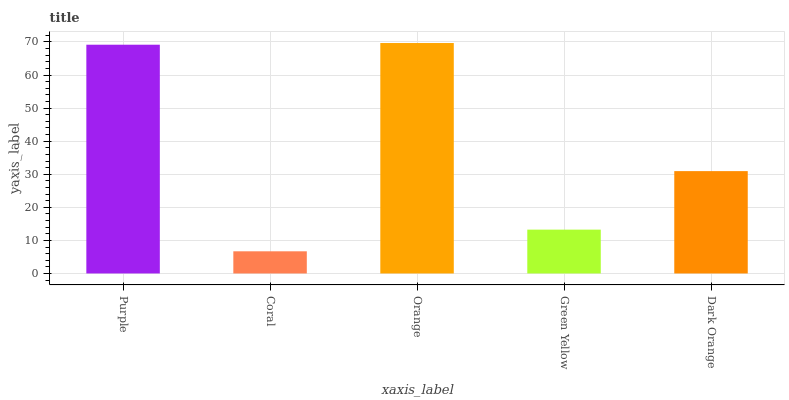Is Coral the minimum?
Answer yes or no. Yes. Is Orange the maximum?
Answer yes or no. Yes. Is Orange the minimum?
Answer yes or no. No. Is Coral the maximum?
Answer yes or no. No. Is Orange greater than Coral?
Answer yes or no. Yes. Is Coral less than Orange?
Answer yes or no. Yes. Is Coral greater than Orange?
Answer yes or no. No. Is Orange less than Coral?
Answer yes or no. No. Is Dark Orange the high median?
Answer yes or no. Yes. Is Dark Orange the low median?
Answer yes or no. Yes. Is Orange the high median?
Answer yes or no. No. Is Purple the low median?
Answer yes or no. No. 